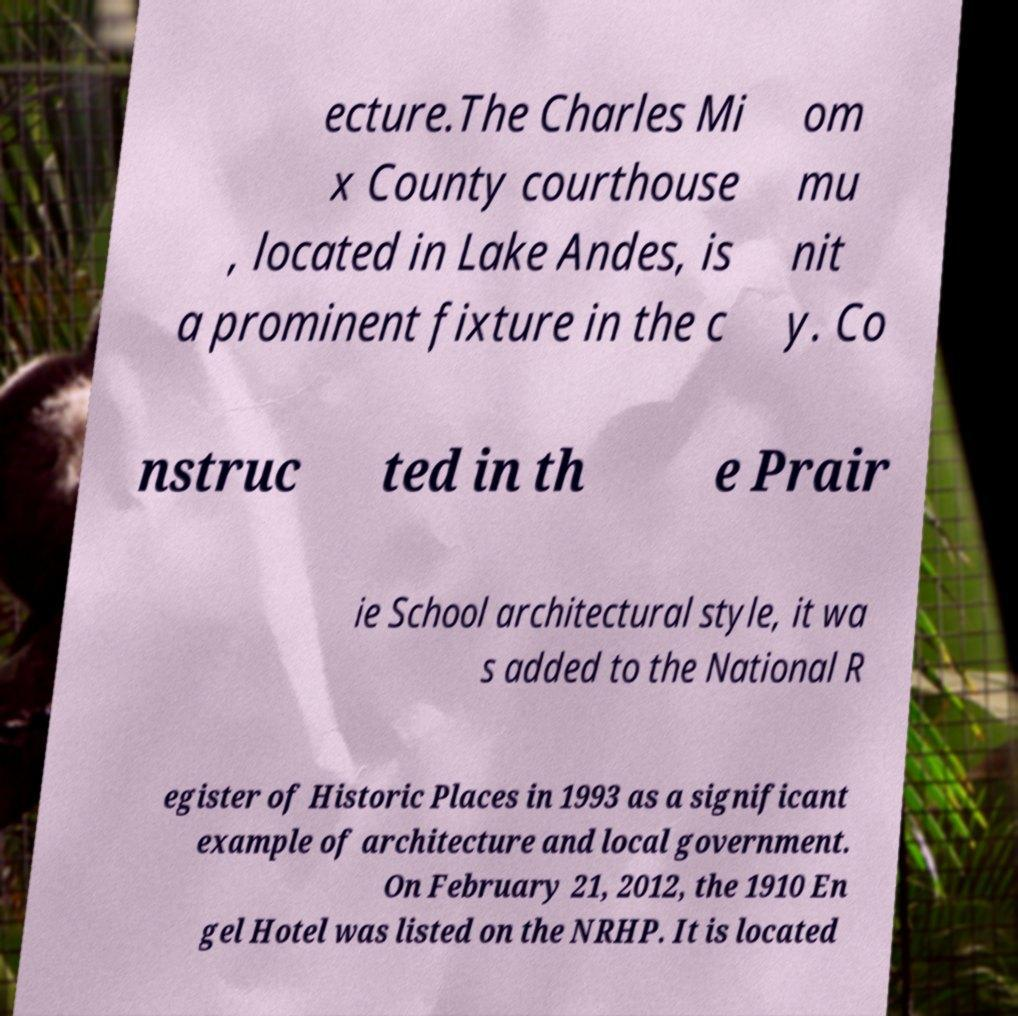Can you accurately transcribe the text from the provided image for me? ecture.The Charles Mi x County courthouse , located in Lake Andes, is a prominent fixture in the c om mu nit y. Co nstruc ted in th e Prair ie School architectural style, it wa s added to the National R egister of Historic Places in 1993 as a significant example of architecture and local government. On February 21, 2012, the 1910 En gel Hotel was listed on the NRHP. It is located 